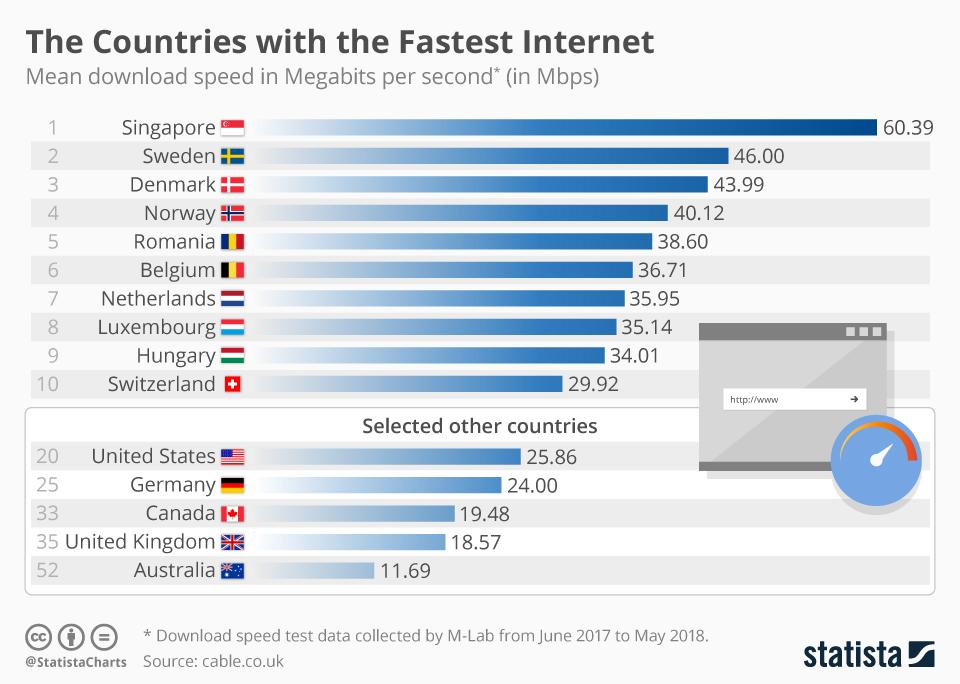List a handful of essential elements in this visual. The country with the third highest download speed among the selected countries is Canada. Four countries have mean download speeds above 40.00 Mbps. According to the information provided, Sweden has the second-highest internet speed among the first ten countries. The test was conducted from June 2017 to May 2018. 